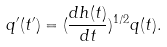Convert formula to latex. <formula><loc_0><loc_0><loc_500><loc_500>q ^ { \prime } ( t ^ { \prime } ) = ( \frac { d h ( t ) } { d t } ) ^ { 1 / 2 } q ( t ) .</formula> 